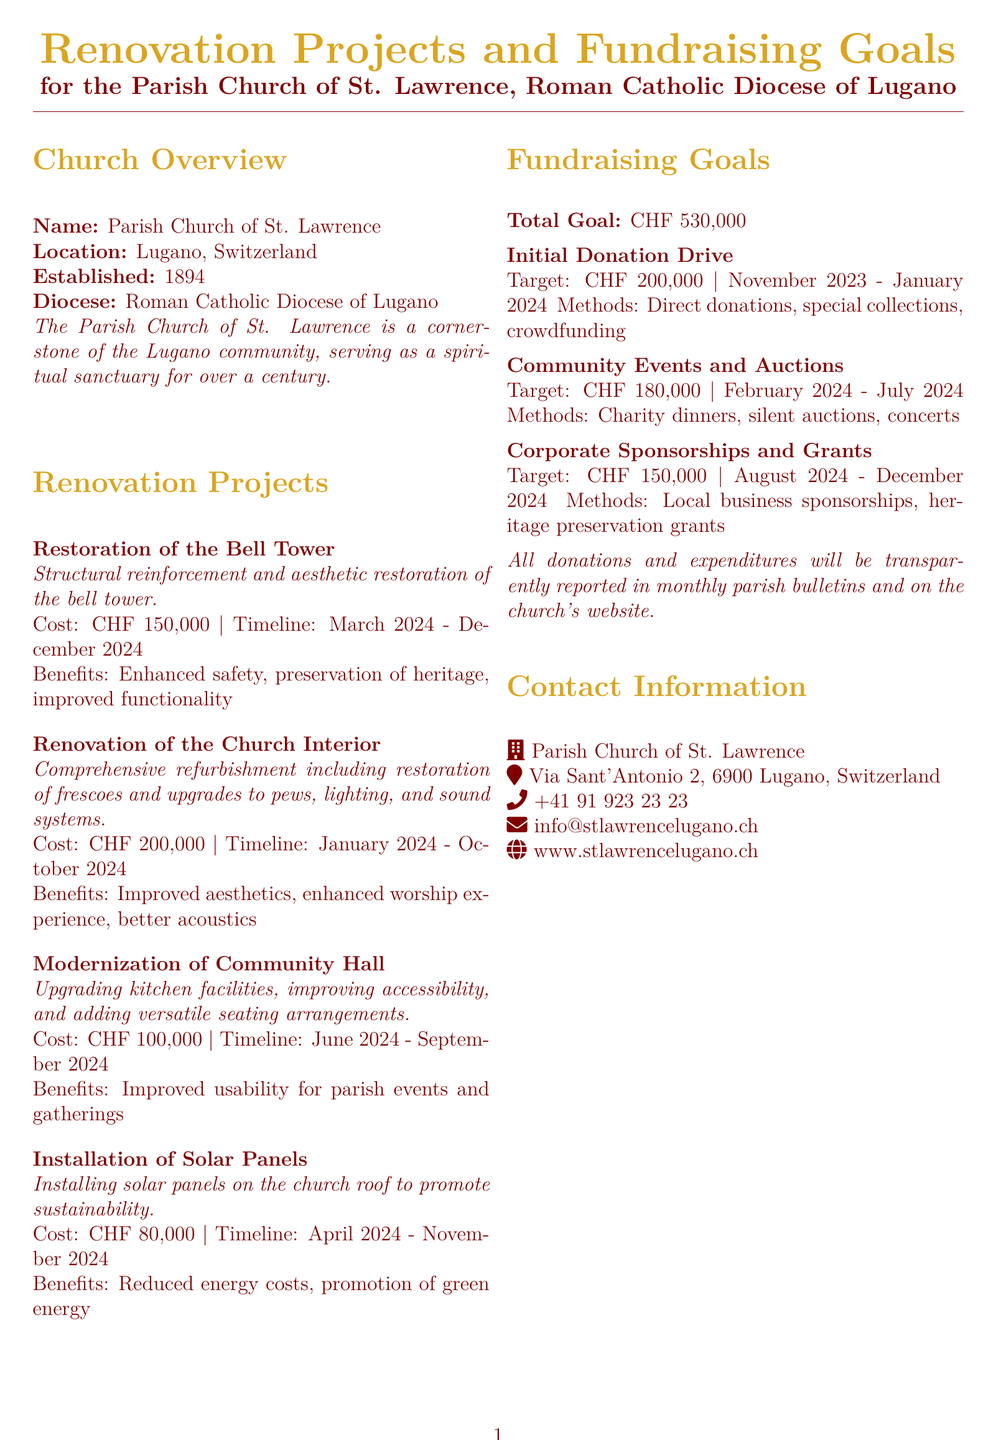What is the parish church's name? The document provides the name of the church as the "Parish Church of St. Lawrence."
Answer: Parish Church of St. Lawrence What is the total fundraising goal? The total fundraising goal is explicitly stated in the document.
Answer: CHF 530,000 When will the restoration of the bell tower take place? The document specifies the timeline for the project from March to December 2024.
Answer: March 2024 - December 2024 What is one benefit of modernizing the community hall? The benefits of the community hall renovation include improved usability for parish events and gatherings.
Answer: Improved usability for parish events and gatherings How much is allocated for the installation of solar panels? The document mentions the cost specifically for this renovation project.
Answer: CHF 80,000 What is a method for the initial donation drive? The methods for fundraising in this phase include "direct donations."
Answer: Direct donations What is the address of the Parish Church of St. Lawrence? The document includes the complete address of the church located in Lugano.
Answer: Via Sant'Antonio 2, 6900 Lugano, Switzerland What is the timeline for community events and auctions? The document outlines when community events and auctions will occur, providing a specific range of months.
Answer: February 2024 - July 2024 What is one of the methods for corporate sponsorships? The document notes one method specifically for this fundraising phase.
Answer: Local business sponsorships 